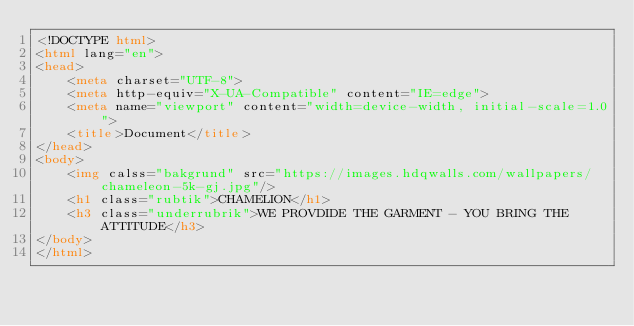<code> <loc_0><loc_0><loc_500><loc_500><_HTML_><!DOCTYPE html>
<html lang="en">
<head>
    <meta charset="UTF-8">
    <meta http-equiv="X-UA-Compatible" content="IE=edge">
    <meta name="viewport" content="width=device-width, initial-scale=1.0">
    <title>Document</title>
</head>
<body>
    <img calss="bakgrund" src="https://images.hdqwalls.com/wallpapers/chameleon-5k-gj.jpg"/>
    <h1 class="rubtik">CHAMELION</h1>
    <h3 class="underrubrik">WE PROVDIDE THE GARMENT - YOU BRING THE ATTITUDE</h3>
</body>
</html></code> 